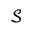<formula> <loc_0><loc_0><loc_500><loc_500>\mathcal { S }</formula> 